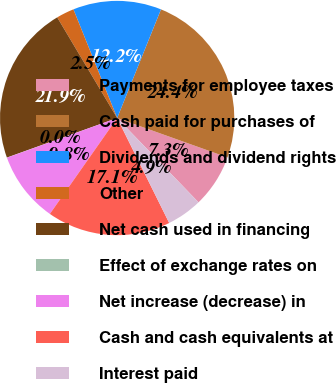<chart> <loc_0><loc_0><loc_500><loc_500><pie_chart><fcel>Payments for employee taxes<fcel>Cash paid for purchases of<fcel>Dividends and dividend rights<fcel>Other<fcel>Net cash used in financing<fcel>Effect of exchange rates on<fcel>Net increase (decrease) in<fcel>Cash and cash equivalents at<fcel>Interest paid<nl><fcel>7.32%<fcel>24.36%<fcel>12.19%<fcel>2.46%<fcel>21.93%<fcel>0.02%<fcel>9.76%<fcel>17.06%<fcel>4.89%<nl></chart> 